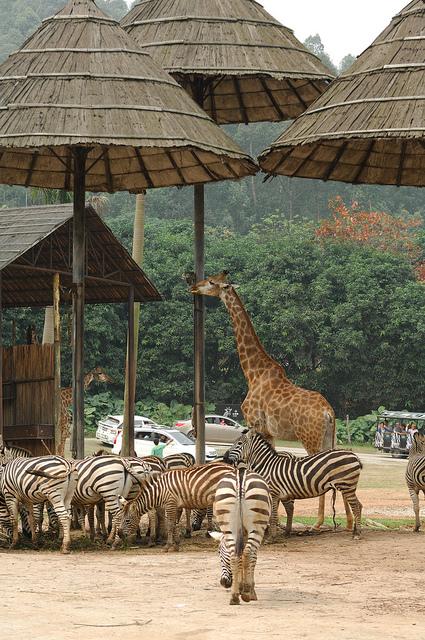How many different kinds of animals are in the picture?
Concise answer only. 2. Are there cars near the animals?
Keep it brief. Yes. Does the giraffe seem to be interacting with the zebras?
Be succinct. No. 